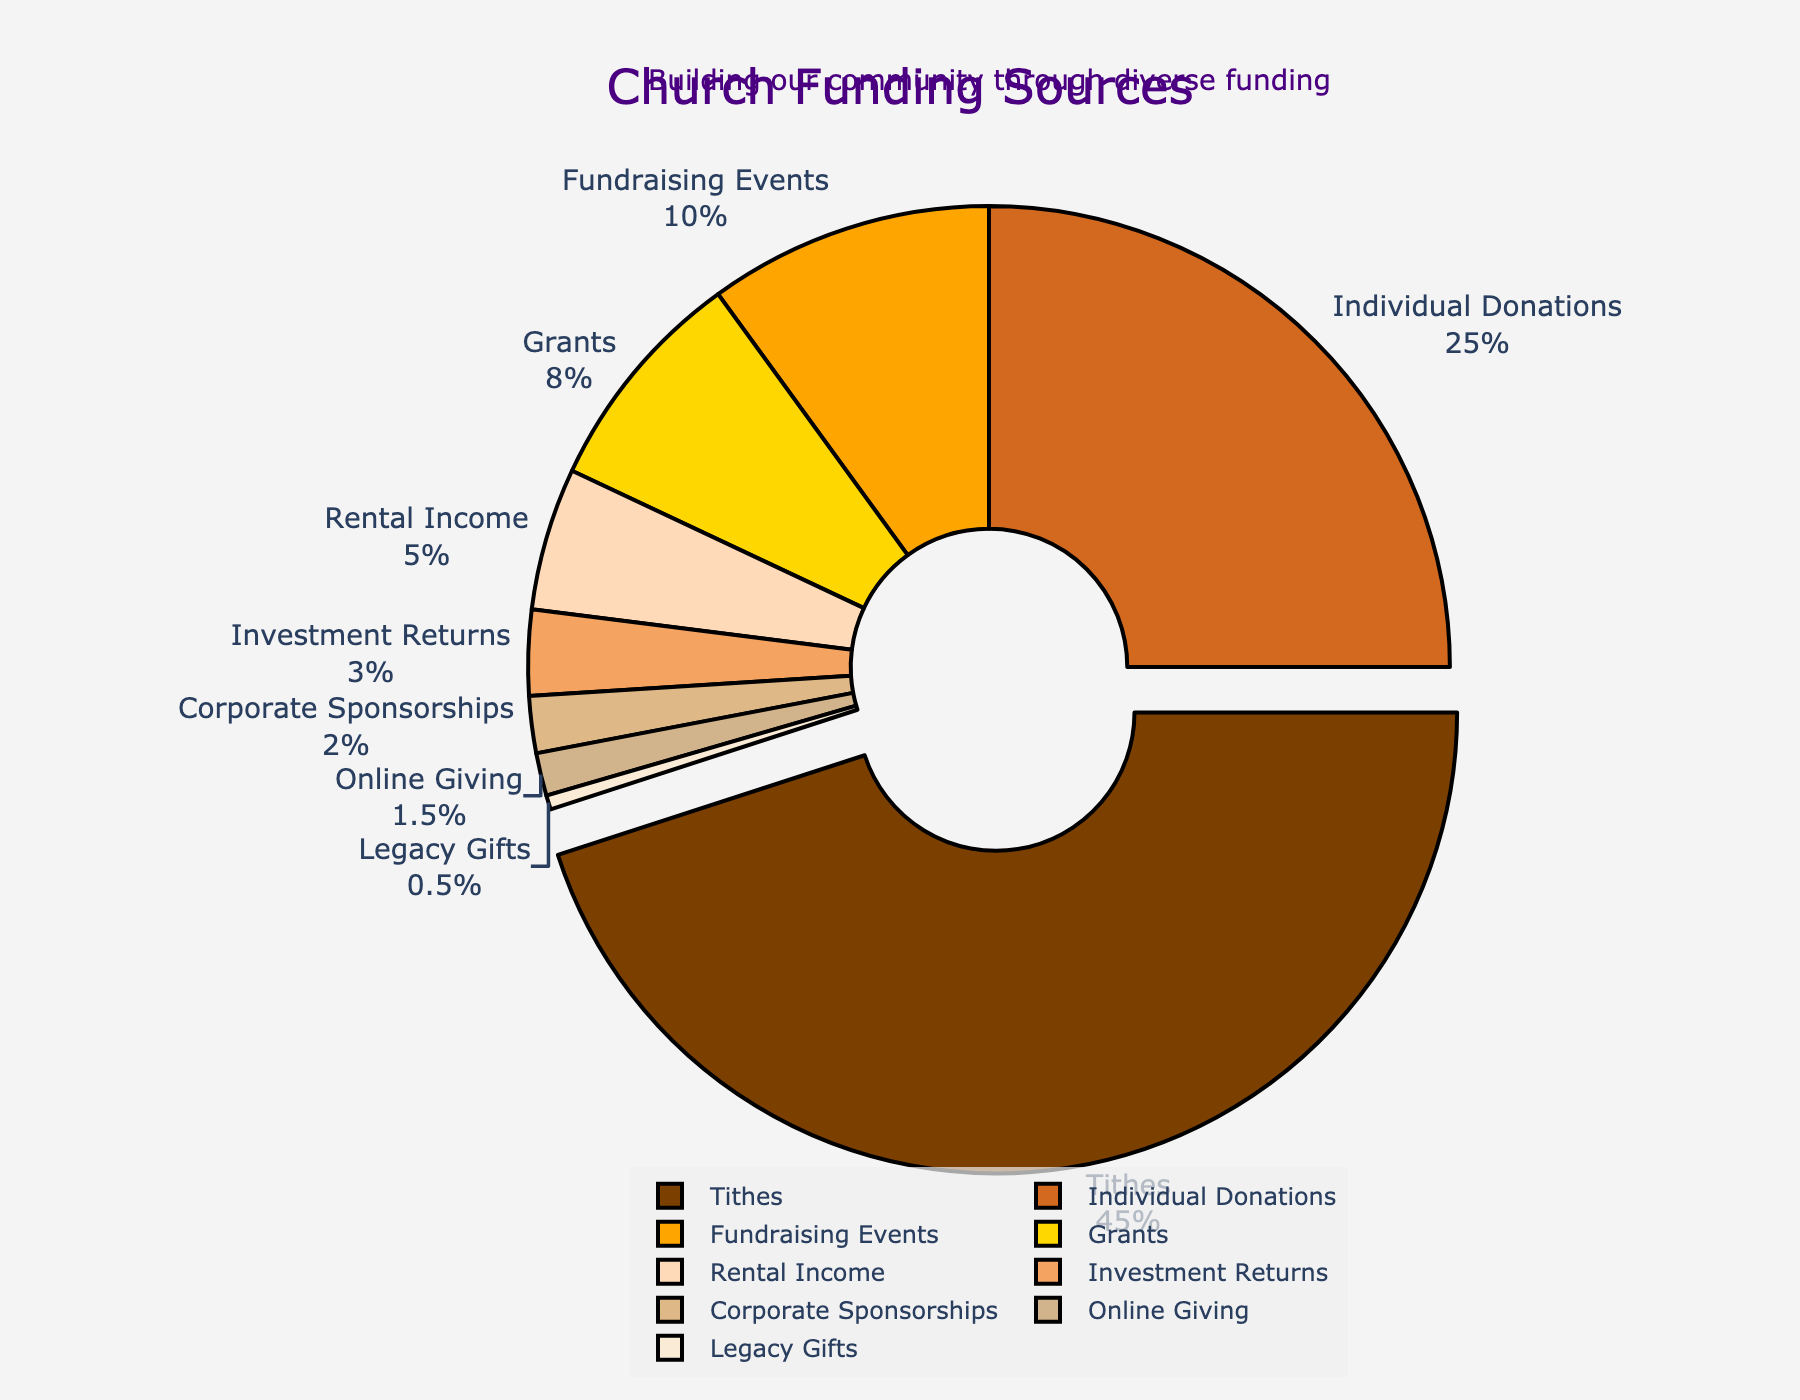Which category has the highest percentage contribution to the church's budget? The figure shows that "Tithes" has the largest slice of the pie chart.
Answer: Tithes What is the combined percentage of Individual Donations, Fundraising Events, and Online Giving? Individual Donations are 25%, Fundraising Events are 10%, and Online Giving is 1.5%. Summing these values: 25 + 10 + 1.5 = 36.5%.
Answer: 36.5% Which funding source contributes less, Corporate Sponsorships or Rental Income? The figure shows Corporate Sponsorships at 2% and Rental Income at 5%. 2% is less than 5%.
Answer: Corporate Sponsorships How much larger is the percentage contribution of Tithes compared to Grants? Tithes contribute 45% and Grants contribute 8%. The difference is 45 - 8 = 37%.
Answer: 37% What percentage of the church’s budget comes from sources other than Tithes? Tithes contribute 45%, so the remaining percentage is 100 - 45 = 55%.
Answer: 55% What are the top three funding sources for the church's annual budget? According to the figure, the top three sources are Tithes (45%), Individual Donations (25%), and Fundraising Events (10%).
Answer: Tithes, Individual Donations, Fundraising Events Is the contribution of Investment Returns closer in value to Grants or to Corporate Sponsorships? Investment Returns are at 3%, Grants are at 8%, and Corporate Sponsorships are at 2%. 3% is closer to 2% than to 8%.
Answer: Corporate Sponsorships What is the average percentage contribution of Rental Income, Investment Returns, and Legacy Gifts? Rental Income is 5%, Investment Returns is 3%, and Legacy Gifts is 0.5%. The sum is 5 + 3 + 0.5 = 8.5%. The average is 8.5 / 3 = approximately 2.83%.
Answer: 2.83% Which category has the smallest contribution and what percentage is it? The smallest slice in the pie chart corresponds to Legacy Gifts, which is 0.5%.
Answer: Legacy Gifts, 0.5% Which three funding sources make up exactly half of the church’s budget combined? Combined percentage of the three highest sources: Tithes (45%), Individual Donations (25%), and Fundraising Events (10%). Their sum is 45 + 25 + 10 = 80%, exceeding half. Checking combinations under half: Individual Donations (25%), Fundraising Events (10%), and Online Giving (1.5%) sum to 36.5%. This is under half, so correct combination found: Tithes (45%) + Grants (8%) + Rental Income (5%) = 58%. No exact match, so nearest is 45 + 10 + 5 = 60%.
Answer: No exact combination 